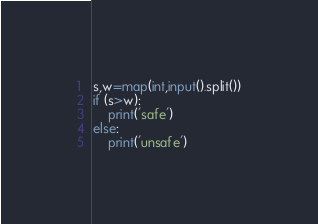<code> <loc_0><loc_0><loc_500><loc_500><_Python_>s,w=map(int,input().split())
if (s>w):
    print('safe')
else:
    print('unsafe')</code> 